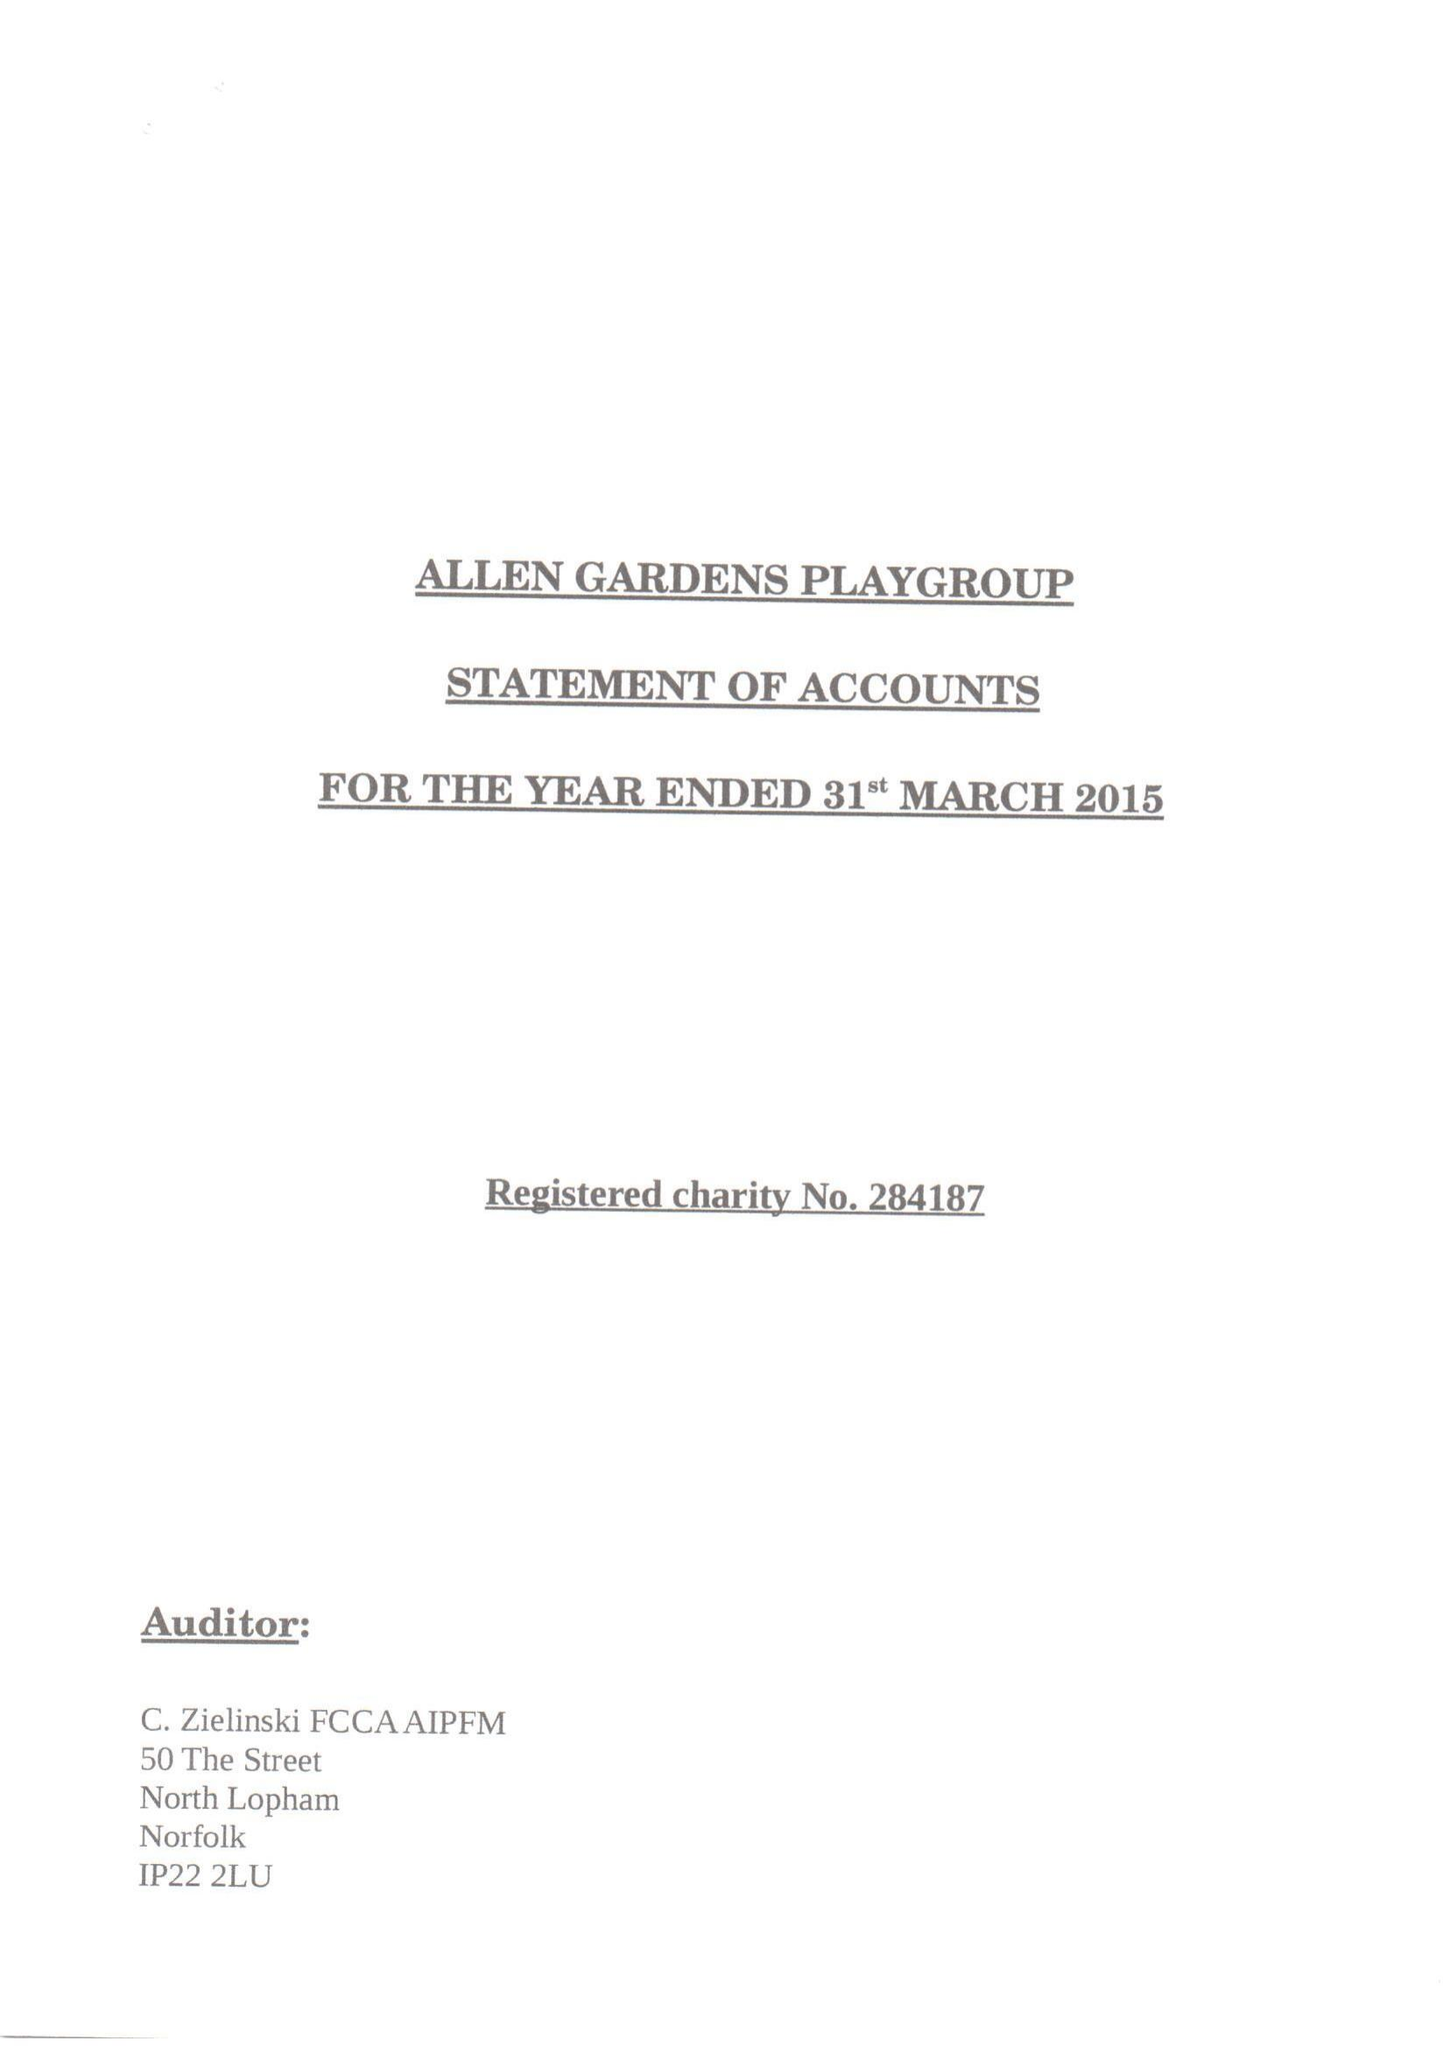What is the value for the address__post_town?
Answer the question using a single word or phrase. LONDON 